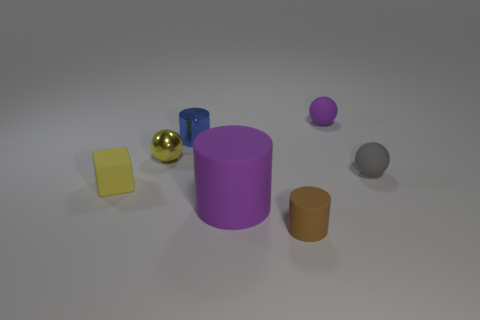What number of blocks are either purple rubber things or small blue things?
Make the answer very short. 0. How many small things are on the right side of the matte block and in front of the tiny blue metallic thing?
Provide a succinct answer. 3. What number of other things are there of the same color as the block?
Ensure brevity in your answer.  1. What is the shape of the purple thing on the left side of the tiny purple thing?
Your answer should be very brief. Cylinder. Does the purple cylinder have the same material as the small brown cylinder?
Offer a very short reply. Yes. Are there any other things that are the same size as the purple matte cylinder?
Your response must be concise. No. What number of tiny purple balls are left of the tiny yellow metal ball?
Your answer should be compact. 0. The purple object to the left of the purple matte object behind the small yellow sphere is what shape?
Your answer should be compact. Cylinder. Are there any other things that are the same shape as the blue object?
Offer a terse response. Yes. Are there more tiny cylinders in front of the gray rubber object than tiny yellow cylinders?
Offer a very short reply. Yes. 